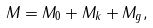<formula> <loc_0><loc_0><loc_500><loc_500>M = M _ { 0 } + M _ { k } + M _ { g } ,</formula> 